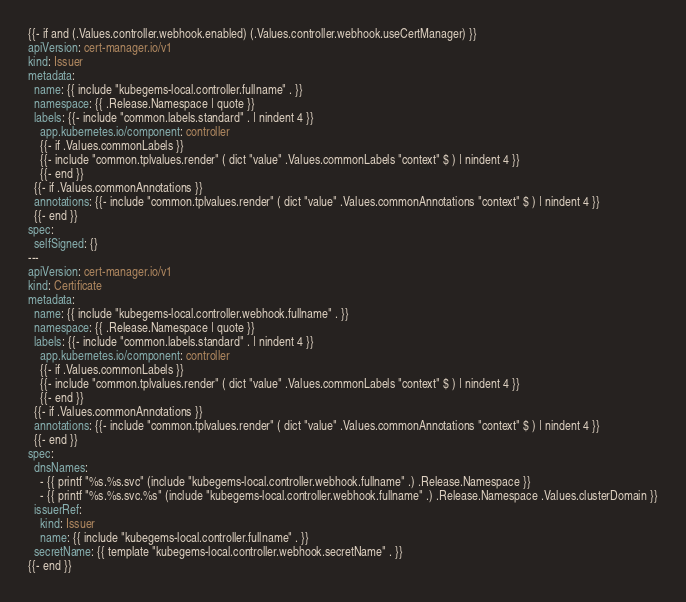Convert code to text. <code><loc_0><loc_0><loc_500><loc_500><_YAML_>
{{- if and (.Values.controller.webhook.enabled) (.Values.controller.webhook.useCertManager) }}
apiVersion: cert-manager.io/v1
kind: Issuer
metadata:
  name: {{ include "kubegems-local.controller.fullname" . }}
  namespace: {{ .Release.Namespace | quote }}
  labels: {{- include "common.labels.standard" . | nindent 4 }}
    app.kubernetes.io/component: controller
    {{- if .Values.commonLabels }}
    {{- include "common.tplvalues.render" ( dict "value" .Values.commonLabels "context" $ ) | nindent 4 }}
    {{- end }}
  {{- if .Values.commonAnnotations }}
  annotations: {{- include "common.tplvalues.render" ( dict "value" .Values.commonAnnotations "context" $ ) | nindent 4 }}
  {{- end }}
spec:
  selfSigned: {}
---
apiVersion: cert-manager.io/v1
kind: Certificate
metadata:
  name: {{ include "kubegems-local.controller.webhook.fullname" . }}
  namespace: {{ .Release.Namespace | quote }}
  labels: {{- include "common.labels.standard" . | nindent 4 }}
    app.kubernetes.io/component: controller
    {{- if .Values.commonLabels }}
    {{- include "common.tplvalues.render" ( dict "value" .Values.commonLabels "context" $ ) | nindent 4 }}
    {{- end }}
  {{- if .Values.commonAnnotations }}
  annotations: {{- include "common.tplvalues.render" ( dict "value" .Values.commonAnnotations "context" $ ) | nindent 4 }}
  {{- end }}
spec:
  dnsNames:
    - {{ printf "%s.%s.svc" (include "kubegems-local.controller.webhook.fullname" .) .Release.Namespace }}
    - {{ printf "%s.%s.svc.%s" (include "kubegems-local.controller.webhook.fullname" .) .Release.Namespace .Values.clusterDomain }}
  issuerRef:
    kind: Issuer
    name: {{ include "kubegems-local.controller.fullname" . }}
  secretName: {{ template "kubegems-local.controller.webhook.secretName" . }}
{{- end }}
</code> 